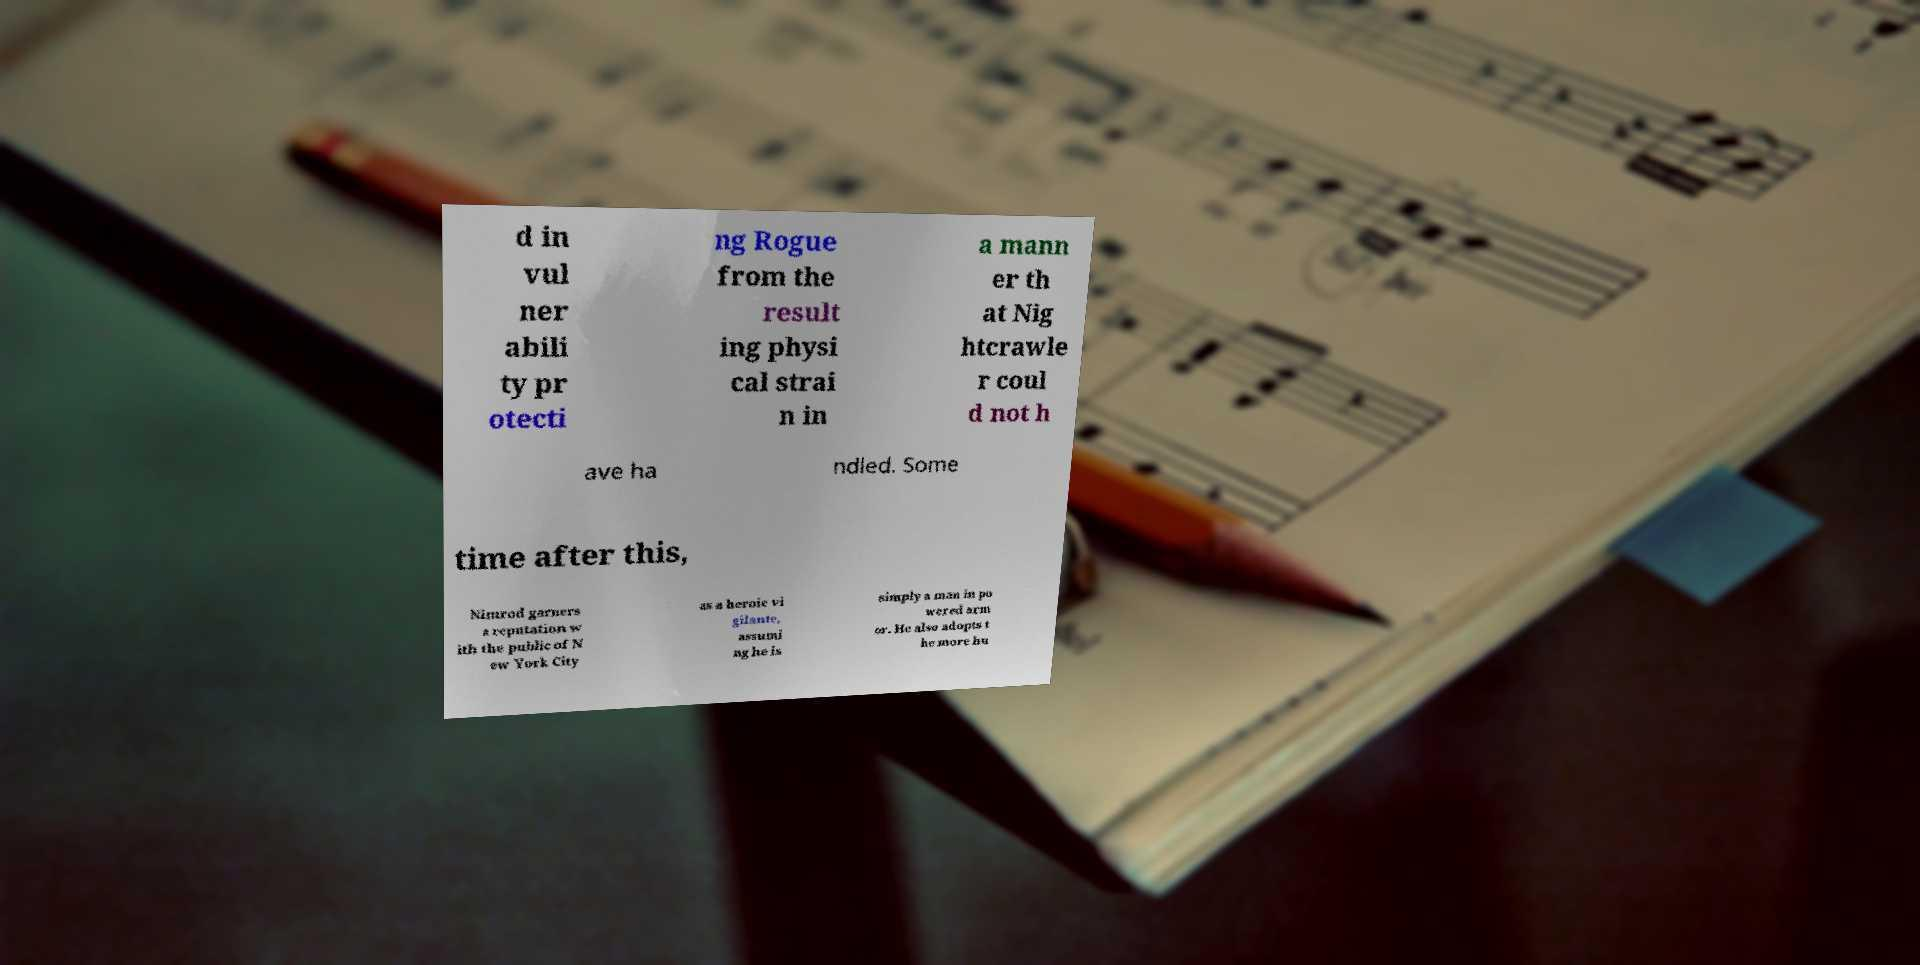Can you read and provide the text displayed in the image?This photo seems to have some interesting text. Can you extract and type it out for me? d in vul ner abili ty pr otecti ng Rogue from the result ing physi cal strai n in a mann er th at Nig htcrawle r coul d not h ave ha ndled. Some time after this, Nimrod garners a reputation w ith the public of N ew York City as a heroic vi gilante, assumi ng he is simply a man in po wered arm or. He also adopts t he more hu 